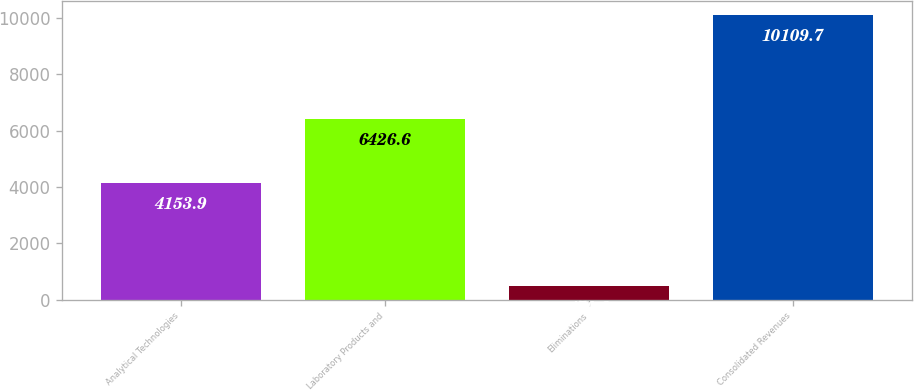Convert chart. <chart><loc_0><loc_0><loc_500><loc_500><bar_chart><fcel>Analytical Technologies<fcel>Laboratory Products and<fcel>Eliminations<fcel>Consolidated Revenues<nl><fcel>4153.9<fcel>6426.6<fcel>470.8<fcel>10109.7<nl></chart> 